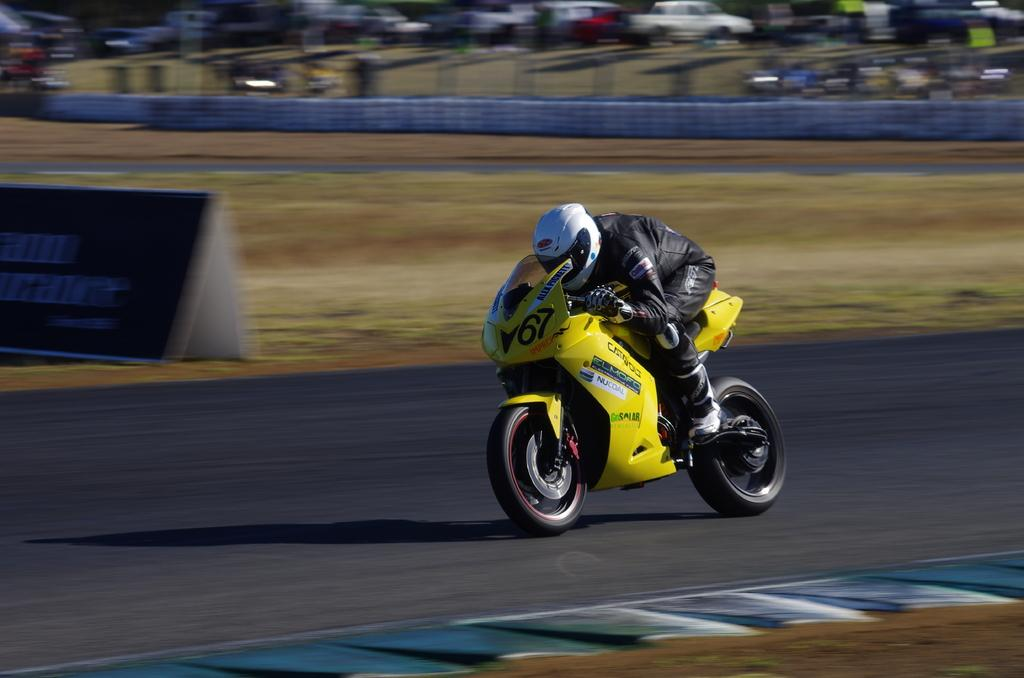What is the person in the image doing? The person is riding a bike on the road. What else can be seen in the image besides the person on the bike? There is a board visible in the image. Are there any other vehicles present in the image? Yes, there are vehicles present in the image. What day of the week is it in the image? The day of the week cannot be determined from the image. What part of the bike is the person using to ride it? The image does not show a specific part of the bike being used by the person to ride it. 